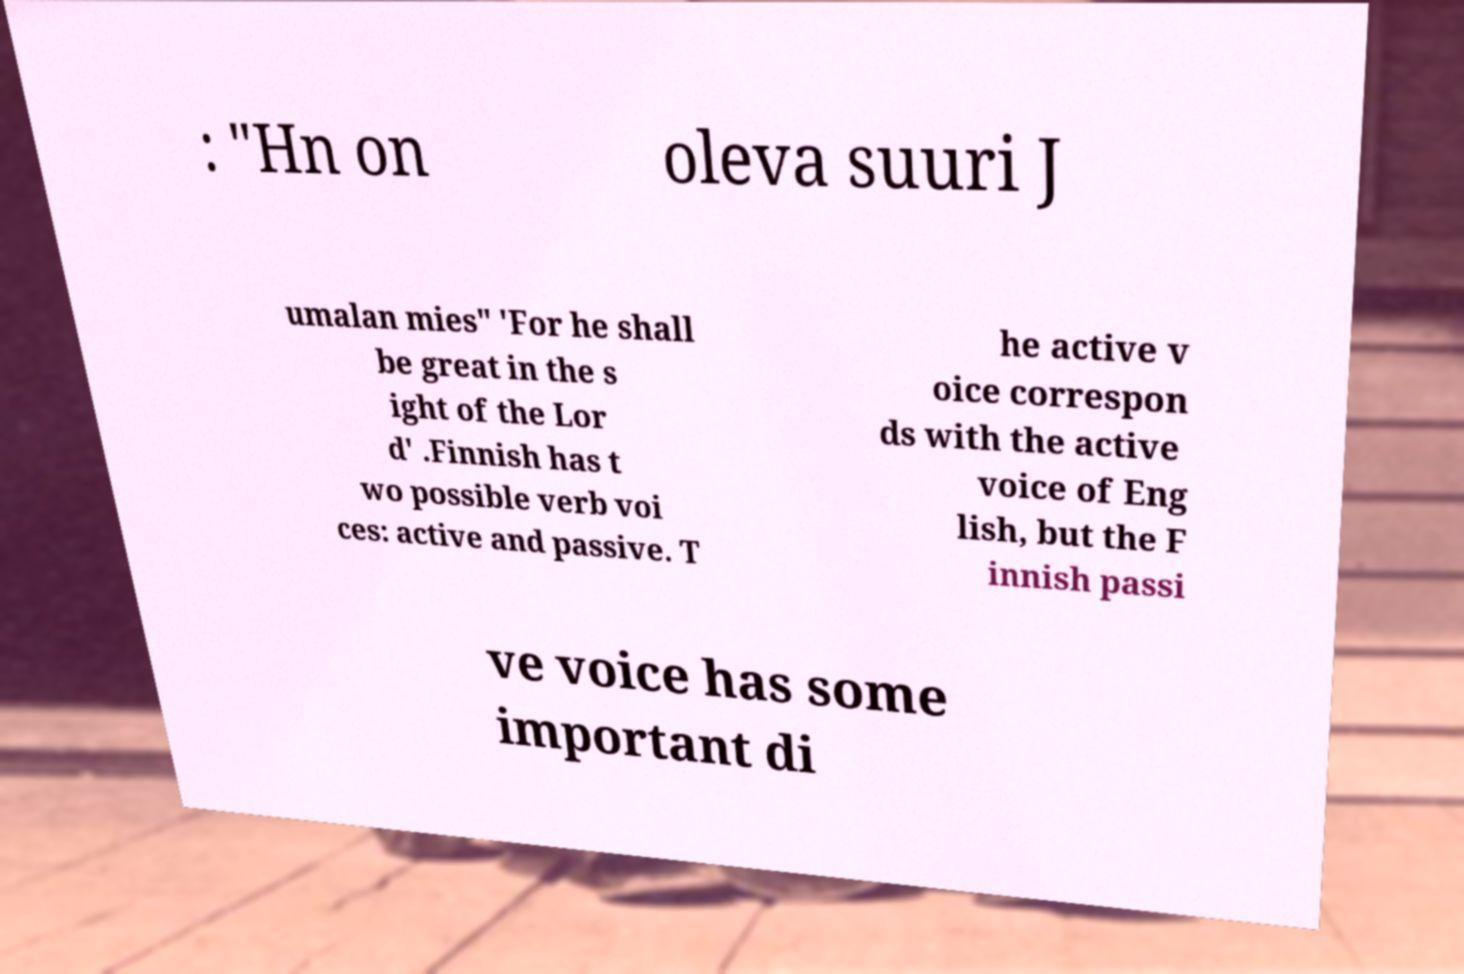I need the written content from this picture converted into text. Can you do that? : "Hn on oleva suuri J umalan mies" 'For he shall be great in the s ight of the Lor d' .Finnish has t wo possible verb voi ces: active and passive. T he active v oice correspon ds with the active voice of Eng lish, but the F innish passi ve voice has some important di 